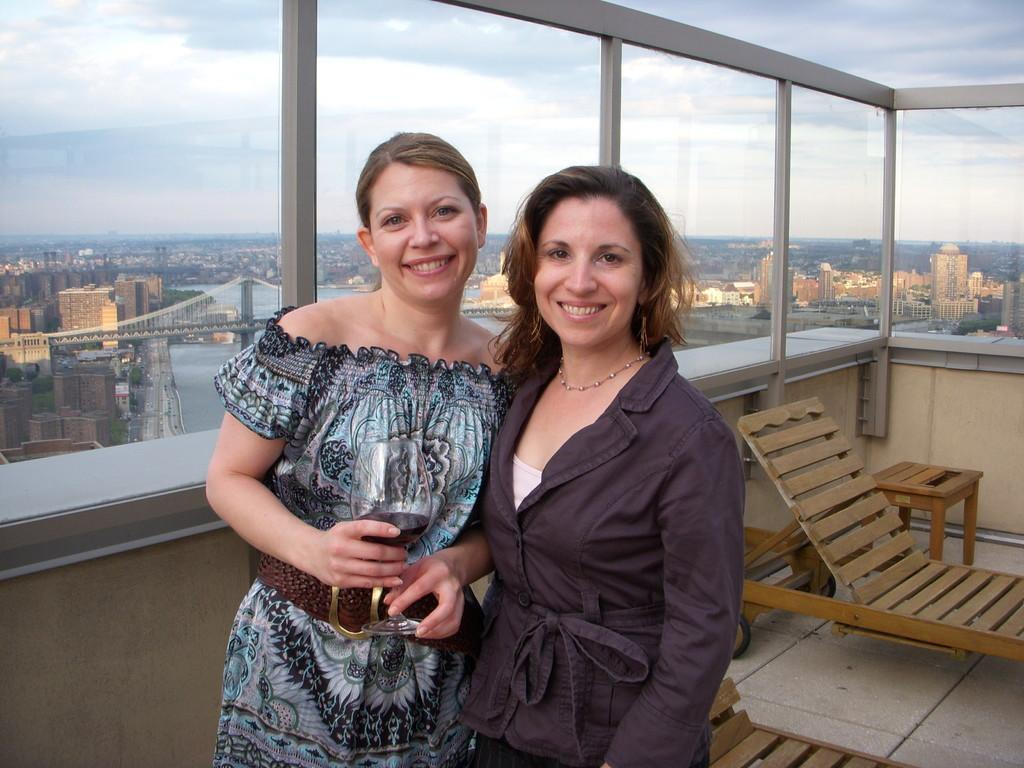How many women are present in the image? There are two women standing in the image. What type of furniture can be seen in the image? There are wooden chairs in the image. What material are the walls made of in the image? The walls are made of glass in the image. What can be seen on the other side of the glass walls? Buildings and bridges on the water can be seen on the other side of the glass walls. What taste does the self-proclaimed "good-bye" have in the image? There is no mention of taste, good-bye, or self in the image. The image features two women, wooden chairs, glass walls, buildings, and bridges on the water. 